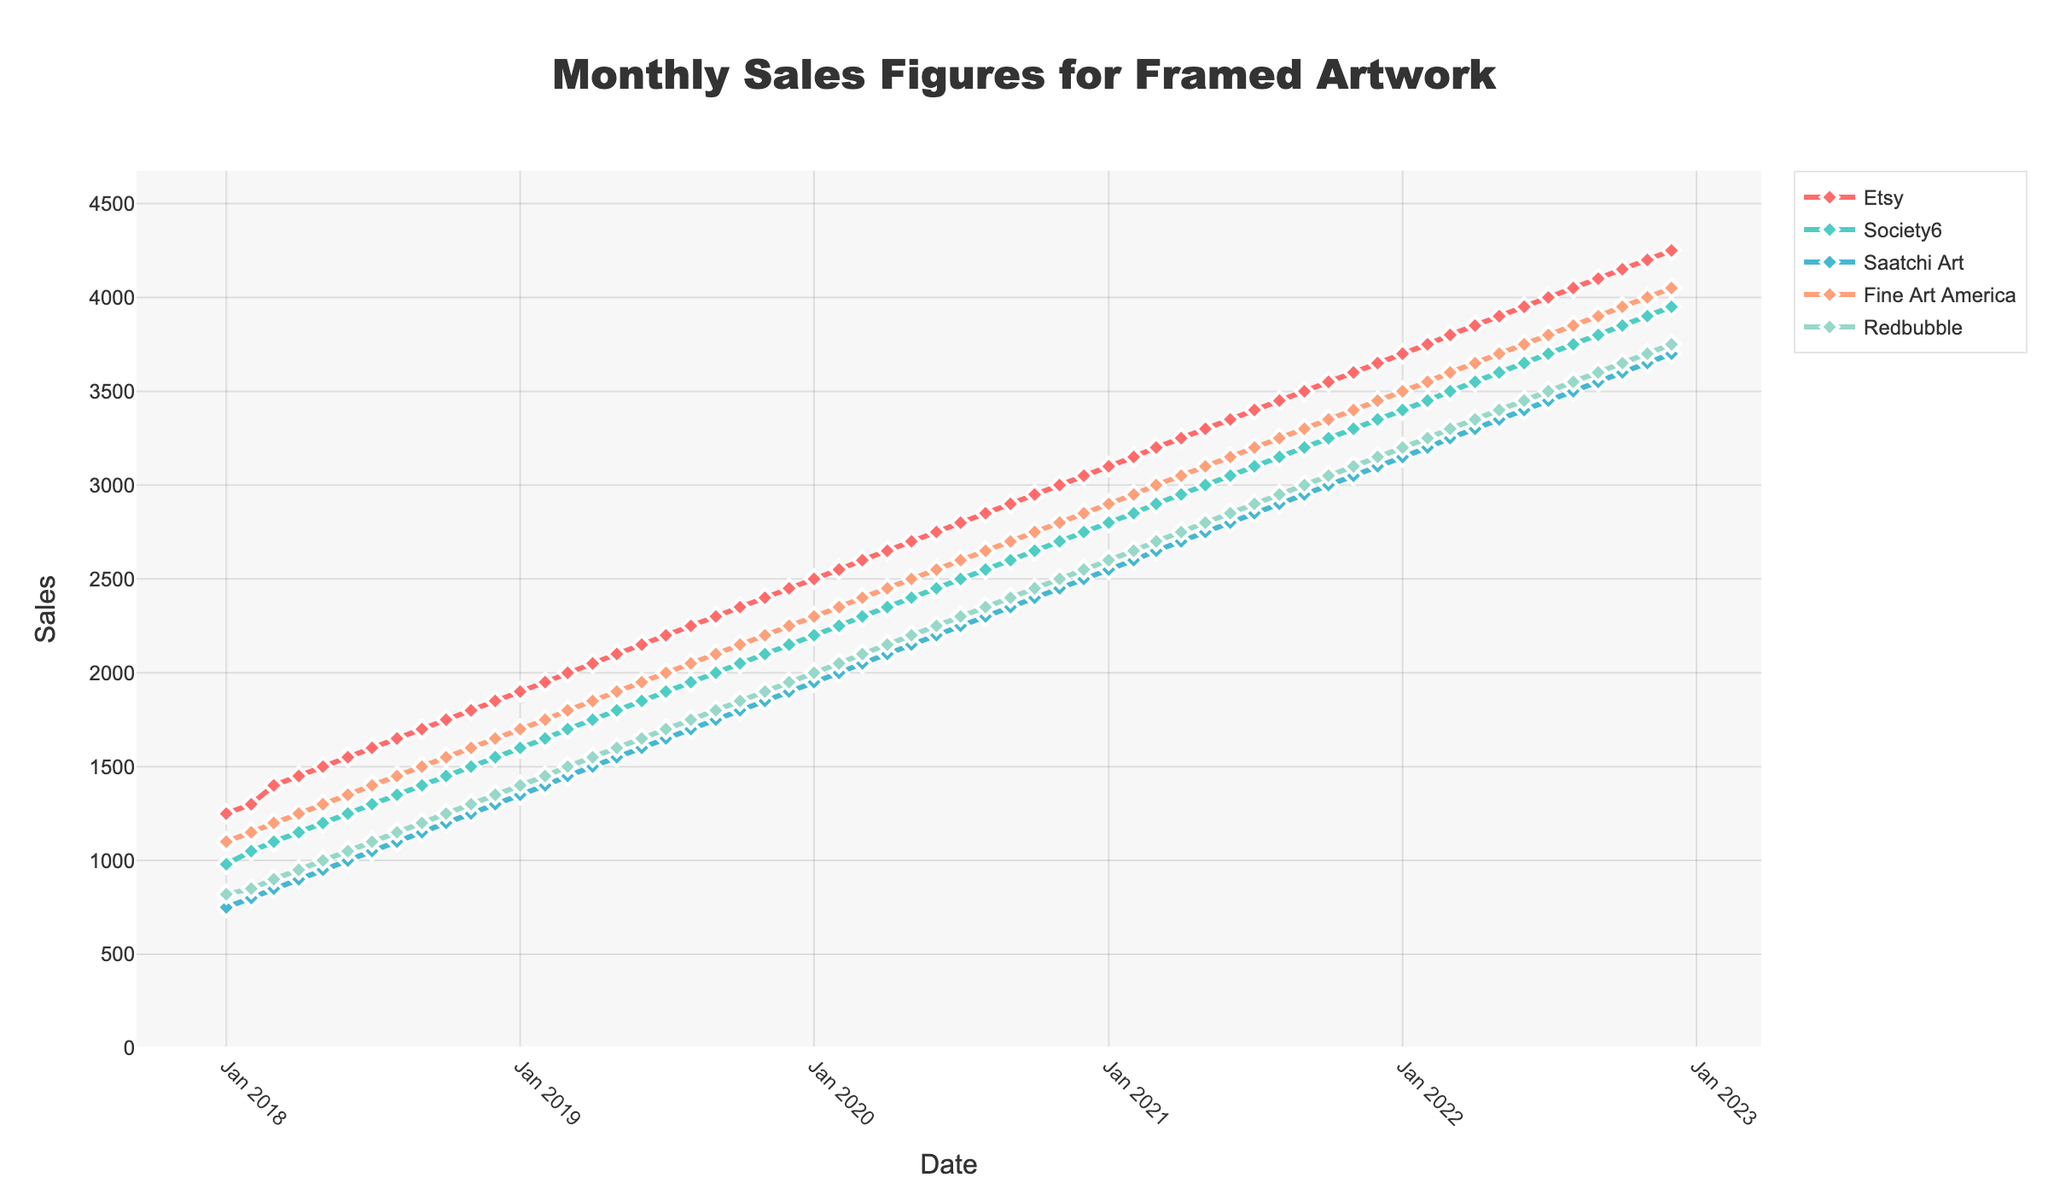Which marketplace had the highest sales in December 2022? Look for the highest point in December 2022. The sales figures are marked on the y-axis, and the corresponding marketplace can be identified by the color-coded legend.
Answer: Etsy Between which months in 2020 did Etsy experience the most significant sales increase? Identify the months with the most noticeable vertical distance between them for the Etsy line (red) within the year 2020. The biggest jump occurs between Jan 2020 and Dec 2020.
Answer: Jan 2020 - Dec 2020 What's the average sales figure for Fine Art America in 2019? Sum the sales figures for Fine Art America (orange) in 2019 and divide by the number of months (12): (1700+1750+1800+1850+1900+1950+2000+2050+2100+2150+2200+2250)/12
Answer: 1950 How did Society6's sales in December 2021 compare to those in January 2021? Look at the points for Society6 (green) in Dec 2021 and Jan 2021, subtract the Jan value from the Dec value: 3350 - 2800 = 550.
Answer: Increased by 550 During which year did Saatchi Art's sales see the most steady increase? Visually inspect the slope of the line representing Saatchi Art (cyan) for each year. The line looks most consistently upward in 2019.
Answer: 2019 Comparing the sales of Redbubble and Society6 in March 2020, which had higher sales, and by how much? Look at the points for Redbubble (light green) and Society6 (green) in March 2020 and subtract Society6's value from Redbubble's: 2100 - 2300 = -200.
Answer: Society6, by 200 What was the overall trend in sales for Etsy from 2018 to 2022? Trace the red line from the start (2018) to the end (2022). The line shows a consistent upward trend.
Answer: Increasing Which two marketplaces had the closest sales figures in August 2022, and what were those figures? Observe the points for each marketplace in August 2022 and find the closest values. Redbubble and Fine Art America both had 3850 sales.
Answer: Fine Art America and Redbubble, 3850 What is the difference in sales between the highest and lowest selling marketplaces in December 2019? Identify the highest (Etsy - 2450) and lowest (Saatchi Art - 1900) points in December 2019 and subtract: 2450 - 1900 = 550.
Answer: 550 Which marketplace saw the least overall variation in sales from 2018 to 2022? Visually compare the lines for each marketplace from 2018 to 2022 and see which one is the flattest. Saatchi Art’s line appears to be the flattest with least variation.
Answer: Saatchi Art 